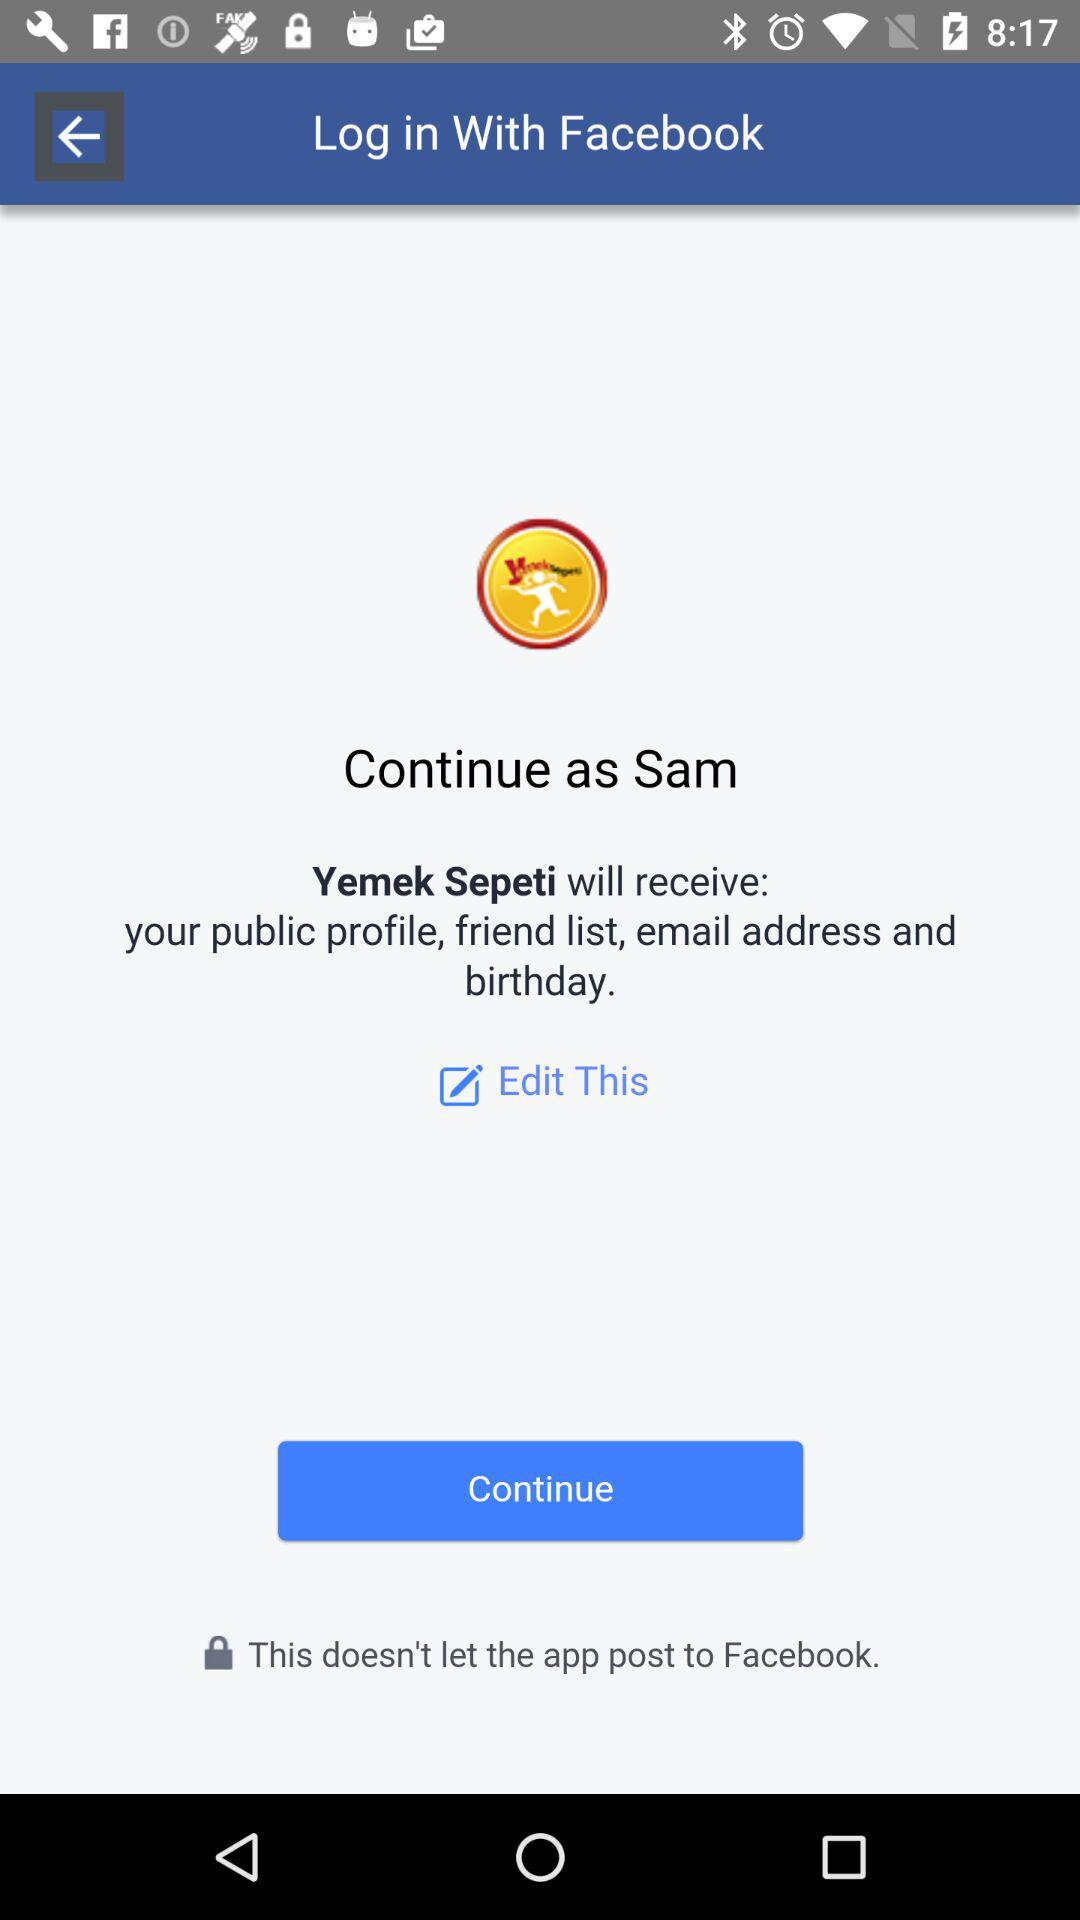Which option is selected?
When the provided information is insufficient, respond with <no answer>. <no answer> 